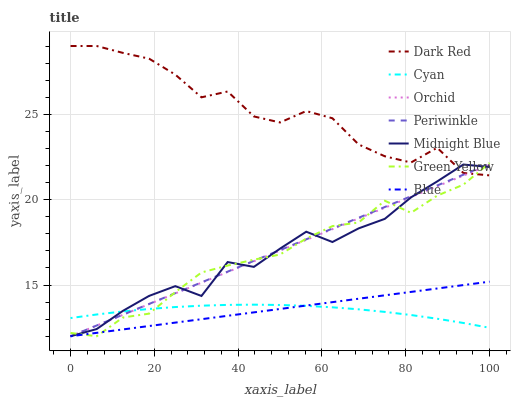Does Cyan have the minimum area under the curve?
Answer yes or no. Yes. Does Dark Red have the maximum area under the curve?
Answer yes or no. Yes. Does Midnight Blue have the minimum area under the curve?
Answer yes or no. No. Does Midnight Blue have the maximum area under the curve?
Answer yes or no. No. Is Blue the smoothest?
Answer yes or no. Yes. Is Dark Red the roughest?
Answer yes or no. Yes. Is Midnight Blue the smoothest?
Answer yes or no. No. Is Midnight Blue the roughest?
Answer yes or no. No. Does Dark Red have the lowest value?
Answer yes or no. No. Does Midnight Blue have the highest value?
Answer yes or no. No. Is Cyan less than Dark Red?
Answer yes or no. Yes. Is Dark Red greater than Cyan?
Answer yes or no. Yes. Does Cyan intersect Dark Red?
Answer yes or no. No. 